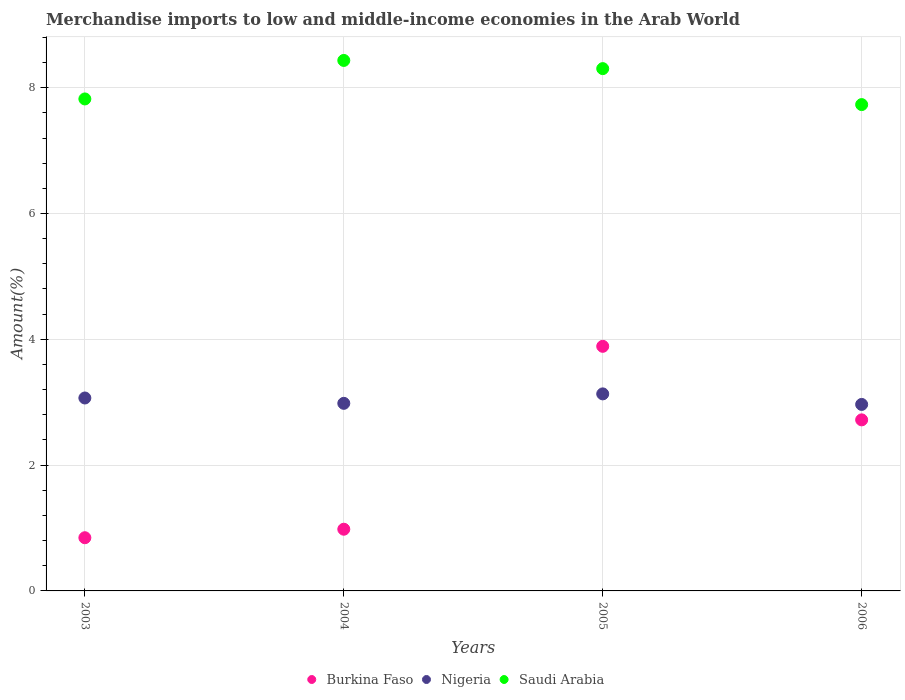How many different coloured dotlines are there?
Your answer should be very brief. 3. Is the number of dotlines equal to the number of legend labels?
Provide a succinct answer. Yes. What is the percentage of amount earned from merchandise imports in Saudi Arabia in 2003?
Make the answer very short. 7.82. Across all years, what is the maximum percentage of amount earned from merchandise imports in Burkina Faso?
Give a very brief answer. 3.89. Across all years, what is the minimum percentage of amount earned from merchandise imports in Burkina Faso?
Provide a succinct answer. 0.85. What is the total percentage of amount earned from merchandise imports in Nigeria in the graph?
Ensure brevity in your answer.  12.15. What is the difference between the percentage of amount earned from merchandise imports in Burkina Faso in 2004 and that in 2005?
Provide a succinct answer. -2.91. What is the difference between the percentage of amount earned from merchandise imports in Nigeria in 2004 and the percentage of amount earned from merchandise imports in Burkina Faso in 2003?
Your answer should be compact. 2.14. What is the average percentage of amount earned from merchandise imports in Burkina Faso per year?
Ensure brevity in your answer.  2.11. In the year 2005, what is the difference between the percentage of amount earned from merchandise imports in Nigeria and percentage of amount earned from merchandise imports in Saudi Arabia?
Make the answer very short. -5.17. In how many years, is the percentage of amount earned from merchandise imports in Nigeria greater than 6.8 %?
Provide a short and direct response. 0. What is the ratio of the percentage of amount earned from merchandise imports in Saudi Arabia in 2004 to that in 2006?
Give a very brief answer. 1.09. Is the difference between the percentage of amount earned from merchandise imports in Nigeria in 2004 and 2006 greater than the difference between the percentage of amount earned from merchandise imports in Saudi Arabia in 2004 and 2006?
Your answer should be very brief. No. What is the difference between the highest and the second highest percentage of amount earned from merchandise imports in Nigeria?
Make the answer very short. 0.07. What is the difference between the highest and the lowest percentage of amount earned from merchandise imports in Saudi Arabia?
Give a very brief answer. 0.7. In how many years, is the percentage of amount earned from merchandise imports in Nigeria greater than the average percentage of amount earned from merchandise imports in Nigeria taken over all years?
Your response must be concise. 2. Is it the case that in every year, the sum of the percentage of amount earned from merchandise imports in Nigeria and percentage of amount earned from merchandise imports in Burkina Faso  is greater than the percentage of amount earned from merchandise imports in Saudi Arabia?
Provide a succinct answer. No. How many dotlines are there?
Provide a short and direct response. 3. Are the values on the major ticks of Y-axis written in scientific E-notation?
Keep it short and to the point. No. Where does the legend appear in the graph?
Your response must be concise. Bottom center. How many legend labels are there?
Give a very brief answer. 3. How are the legend labels stacked?
Offer a terse response. Horizontal. What is the title of the graph?
Your answer should be compact. Merchandise imports to low and middle-income economies in the Arab World. What is the label or title of the Y-axis?
Offer a terse response. Amount(%). What is the Amount(%) of Burkina Faso in 2003?
Offer a very short reply. 0.85. What is the Amount(%) of Nigeria in 2003?
Your response must be concise. 3.07. What is the Amount(%) in Saudi Arabia in 2003?
Provide a short and direct response. 7.82. What is the Amount(%) in Burkina Faso in 2004?
Provide a succinct answer. 0.98. What is the Amount(%) of Nigeria in 2004?
Provide a short and direct response. 2.98. What is the Amount(%) in Saudi Arabia in 2004?
Offer a terse response. 8.43. What is the Amount(%) in Burkina Faso in 2005?
Offer a very short reply. 3.89. What is the Amount(%) in Nigeria in 2005?
Give a very brief answer. 3.13. What is the Amount(%) of Saudi Arabia in 2005?
Keep it short and to the point. 8.3. What is the Amount(%) of Burkina Faso in 2006?
Make the answer very short. 2.72. What is the Amount(%) of Nigeria in 2006?
Your response must be concise. 2.96. What is the Amount(%) of Saudi Arabia in 2006?
Offer a very short reply. 7.73. Across all years, what is the maximum Amount(%) of Burkina Faso?
Provide a short and direct response. 3.89. Across all years, what is the maximum Amount(%) in Nigeria?
Your answer should be very brief. 3.13. Across all years, what is the maximum Amount(%) in Saudi Arabia?
Offer a terse response. 8.43. Across all years, what is the minimum Amount(%) in Burkina Faso?
Offer a very short reply. 0.85. Across all years, what is the minimum Amount(%) in Nigeria?
Ensure brevity in your answer.  2.96. Across all years, what is the minimum Amount(%) in Saudi Arabia?
Your answer should be compact. 7.73. What is the total Amount(%) of Burkina Faso in the graph?
Offer a very short reply. 8.43. What is the total Amount(%) of Nigeria in the graph?
Provide a short and direct response. 12.15. What is the total Amount(%) in Saudi Arabia in the graph?
Your response must be concise. 32.29. What is the difference between the Amount(%) of Burkina Faso in 2003 and that in 2004?
Offer a very short reply. -0.14. What is the difference between the Amount(%) in Nigeria in 2003 and that in 2004?
Ensure brevity in your answer.  0.09. What is the difference between the Amount(%) of Saudi Arabia in 2003 and that in 2004?
Offer a very short reply. -0.61. What is the difference between the Amount(%) in Burkina Faso in 2003 and that in 2005?
Provide a short and direct response. -3.04. What is the difference between the Amount(%) of Nigeria in 2003 and that in 2005?
Make the answer very short. -0.07. What is the difference between the Amount(%) in Saudi Arabia in 2003 and that in 2005?
Your response must be concise. -0.48. What is the difference between the Amount(%) of Burkina Faso in 2003 and that in 2006?
Make the answer very short. -1.87. What is the difference between the Amount(%) in Nigeria in 2003 and that in 2006?
Your answer should be compact. 0.1. What is the difference between the Amount(%) in Saudi Arabia in 2003 and that in 2006?
Provide a succinct answer. 0.09. What is the difference between the Amount(%) of Burkina Faso in 2004 and that in 2005?
Your answer should be very brief. -2.91. What is the difference between the Amount(%) of Nigeria in 2004 and that in 2005?
Your answer should be very brief. -0.15. What is the difference between the Amount(%) of Saudi Arabia in 2004 and that in 2005?
Offer a terse response. 0.13. What is the difference between the Amount(%) in Burkina Faso in 2004 and that in 2006?
Provide a succinct answer. -1.74. What is the difference between the Amount(%) in Nigeria in 2004 and that in 2006?
Your response must be concise. 0.02. What is the difference between the Amount(%) of Saudi Arabia in 2004 and that in 2006?
Ensure brevity in your answer.  0.7. What is the difference between the Amount(%) of Burkina Faso in 2005 and that in 2006?
Ensure brevity in your answer.  1.17. What is the difference between the Amount(%) of Nigeria in 2005 and that in 2006?
Offer a terse response. 0.17. What is the difference between the Amount(%) in Saudi Arabia in 2005 and that in 2006?
Ensure brevity in your answer.  0.57. What is the difference between the Amount(%) in Burkina Faso in 2003 and the Amount(%) in Nigeria in 2004?
Your answer should be very brief. -2.14. What is the difference between the Amount(%) in Burkina Faso in 2003 and the Amount(%) in Saudi Arabia in 2004?
Provide a succinct answer. -7.59. What is the difference between the Amount(%) of Nigeria in 2003 and the Amount(%) of Saudi Arabia in 2004?
Make the answer very short. -5.37. What is the difference between the Amount(%) of Burkina Faso in 2003 and the Amount(%) of Nigeria in 2005?
Offer a terse response. -2.29. What is the difference between the Amount(%) of Burkina Faso in 2003 and the Amount(%) of Saudi Arabia in 2005?
Ensure brevity in your answer.  -7.46. What is the difference between the Amount(%) in Nigeria in 2003 and the Amount(%) in Saudi Arabia in 2005?
Give a very brief answer. -5.24. What is the difference between the Amount(%) in Burkina Faso in 2003 and the Amount(%) in Nigeria in 2006?
Provide a short and direct response. -2.12. What is the difference between the Amount(%) in Burkina Faso in 2003 and the Amount(%) in Saudi Arabia in 2006?
Your answer should be compact. -6.89. What is the difference between the Amount(%) of Nigeria in 2003 and the Amount(%) of Saudi Arabia in 2006?
Your answer should be compact. -4.66. What is the difference between the Amount(%) of Burkina Faso in 2004 and the Amount(%) of Nigeria in 2005?
Provide a succinct answer. -2.15. What is the difference between the Amount(%) in Burkina Faso in 2004 and the Amount(%) in Saudi Arabia in 2005?
Your answer should be compact. -7.32. What is the difference between the Amount(%) of Nigeria in 2004 and the Amount(%) of Saudi Arabia in 2005?
Your answer should be very brief. -5.32. What is the difference between the Amount(%) in Burkina Faso in 2004 and the Amount(%) in Nigeria in 2006?
Offer a terse response. -1.98. What is the difference between the Amount(%) of Burkina Faso in 2004 and the Amount(%) of Saudi Arabia in 2006?
Ensure brevity in your answer.  -6.75. What is the difference between the Amount(%) in Nigeria in 2004 and the Amount(%) in Saudi Arabia in 2006?
Offer a terse response. -4.75. What is the difference between the Amount(%) in Burkina Faso in 2005 and the Amount(%) in Nigeria in 2006?
Provide a succinct answer. 0.92. What is the difference between the Amount(%) of Burkina Faso in 2005 and the Amount(%) of Saudi Arabia in 2006?
Offer a terse response. -3.84. What is the difference between the Amount(%) in Nigeria in 2005 and the Amount(%) in Saudi Arabia in 2006?
Offer a terse response. -4.6. What is the average Amount(%) of Burkina Faso per year?
Keep it short and to the point. 2.11. What is the average Amount(%) of Nigeria per year?
Your answer should be very brief. 3.04. What is the average Amount(%) of Saudi Arabia per year?
Provide a succinct answer. 8.07. In the year 2003, what is the difference between the Amount(%) of Burkina Faso and Amount(%) of Nigeria?
Your answer should be very brief. -2.22. In the year 2003, what is the difference between the Amount(%) in Burkina Faso and Amount(%) in Saudi Arabia?
Provide a short and direct response. -6.98. In the year 2003, what is the difference between the Amount(%) in Nigeria and Amount(%) in Saudi Arabia?
Make the answer very short. -4.75. In the year 2004, what is the difference between the Amount(%) in Burkina Faso and Amount(%) in Nigeria?
Keep it short and to the point. -2. In the year 2004, what is the difference between the Amount(%) in Burkina Faso and Amount(%) in Saudi Arabia?
Offer a very short reply. -7.45. In the year 2004, what is the difference between the Amount(%) in Nigeria and Amount(%) in Saudi Arabia?
Keep it short and to the point. -5.45. In the year 2005, what is the difference between the Amount(%) of Burkina Faso and Amount(%) of Nigeria?
Offer a terse response. 0.76. In the year 2005, what is the difference between the Amount(%) in Burkina Faso and Amount(%) in Saudi Arabia?
Provide a succinct answer. -4.41. In the year 2005, what is the difference between the Amount(%) in Nigeria and Amount(%) in Saudi Arabia?
Make the answer very short. -5.17. In the year 2006, what is the difference between the Amount(%) of Burkina Faso and Amount(%) of Nigeria?
Provide a succinct answer. -0.25. In the year 2006, what is the difference between the Amount(%) in Burkina Faso and Amount(%) in Saudi Arabia?
Your answer should be compact. -5.01. In the year 2006, what is the difference between the Amount(%) in Nigeria and Amount(%) in Saudi Arabia?
Your response must be concise. -4.77. What is the ratio of the Amount(%) of Burkina Faso in 2003 to that in 2004?
Give a very brief answer. 0.86. What is the ratio of the Amount(%) in Nigeria in 2003 to that in 2004?
Provide a succinct answer. 1.03. What is the ratio of the Amount(%) of Saudi Arabia in 2003 to that in 2004?
Ensure brevity in your answer.  0.93. What is the ratio of the Amount(%) of Burkina Faso in 2003 to that in 2005?
Your response must be concise. 0.22. What is the ratio of the Amount(%) of Nigeria in 2003 to that in 2005?
Provide a succinct answer. 0.98. What is the ratio of the Amount(%) in Saudi Arabia in 2003 to that in 2005?
Provide a succinct answer. 0.94. What is the ratio of the Amount(%) of Burkina Faso in 2003 to that in 2006?
Offer a very short reply. 0.31. What is the ratio of the Amount(%) in Nigeria in 2003 to that in 2006?
Provide a short and direct response. 1.03. What is the ratio of the Amount(%) of Saudi Arabia in 2003 to that in 2006?
Your response must be concise. 1.01. What is the ratio of the Amount(%) in Burkina Faso in 2004 to that in 2005?
Offer a very short reply. 0.25. What is the ratio of the Amount(%) of Nigeria in 2004 to that in 2005?
Your answer should be very brief. 0.95. What is the ratio of the Amount(%) of Saudi Arabia in 2004 to that in 2005?
Provide a short and direct response. 1.02. What is the ratio of the Amount(%) of Burkina Faso in 2004 to that in 2006?
Your answer should be compact. 0.36. What is the ratio of the Amount(%) in Saudi Arabia in 2004 to that in 2006?
Make the answer very short. 1.09. What is the ratio of the Amount(%) of Burkina Faso in 2005 to that in 2006?
Offer a terse response. 1.43. What is the ratio of the Amount(%) of Nigeria in 2005 to that in 2006?
Your response must be concise. 1.06. What is the ratio of the Amount(%) of Saudi Arabia in 2005 to that in 2006?
Your response must be concise. 1.07. What is the difference between the highest and the second highest Amount(%) of Burkina Faso?
Make the answer very short. 1.17. What is the difference between the highest and the second highest Amount(%) in Nigeria?
Ensure brevity in your answer.  0.07. What is the difference between the highest and the second highest Amount(%) in Saudi Arabia?
Make the answer very short. 0.13. What is the difference between the highest and the lowest Amount(%) of Burkina Faso?
Make the answer very short. 3.04. What is the difference between the highest and the lowest Amount(%) of Nigeria?
Make the answer very short. 0.17. What is the difference between the highest and the lowest Amount(%) in Saudi Arabia?
Make the answer very short. 0.7. 